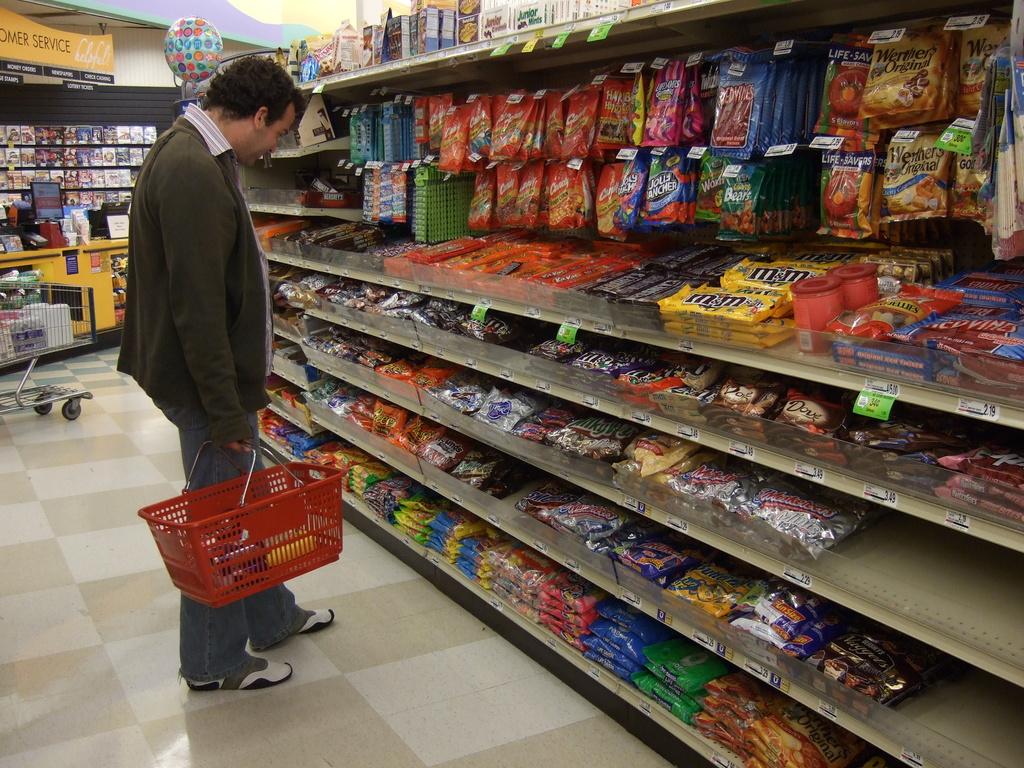What is one visible piece of candy?
Make the answer very short. M&m's. 